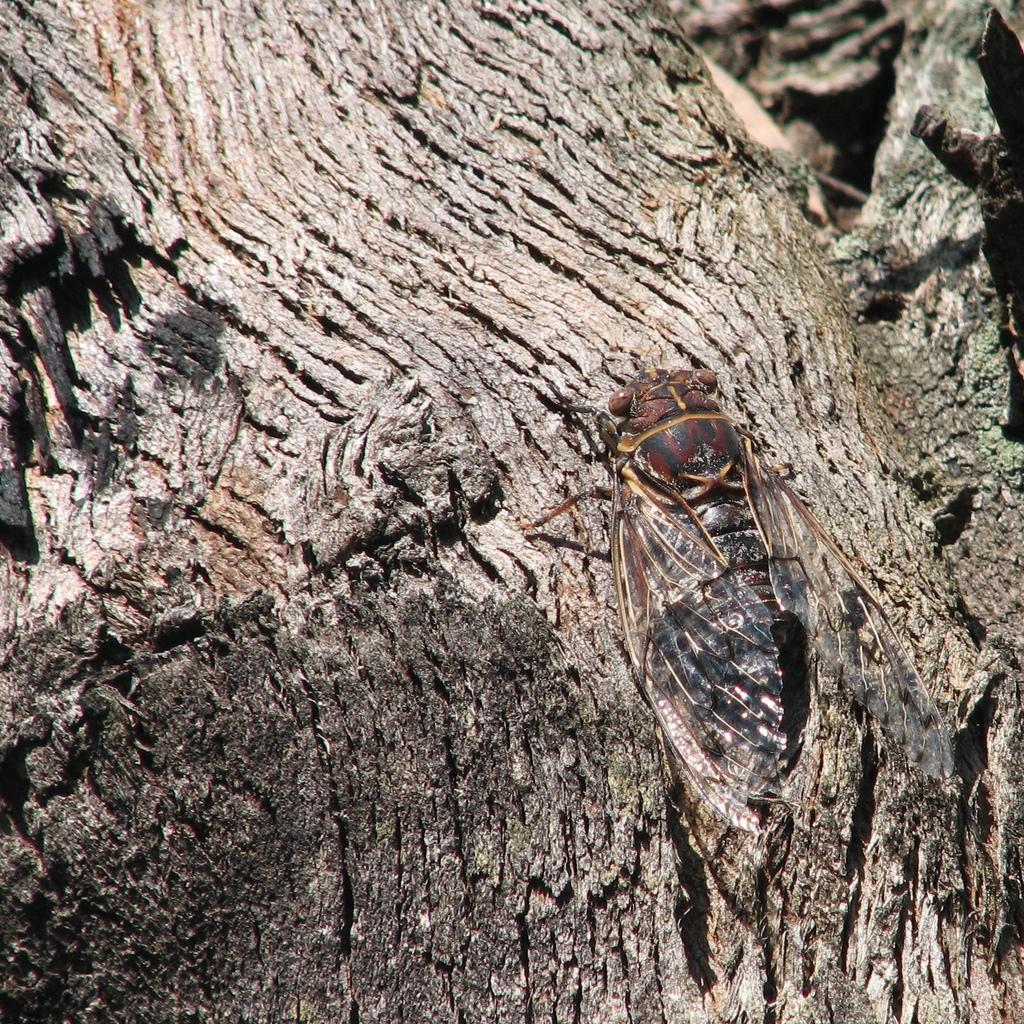What is present on the wooden surface in the image? There is a fly on the wooden surface in the image. Can you describe the wooden surface in the image? The wooden surface is not described in the provided facts, so we cannot provide any details about it. How many knives are visible on the wooden surface in the image? There is no mention of knives in the provided facts, so we cannot determine if any are present in the image. 